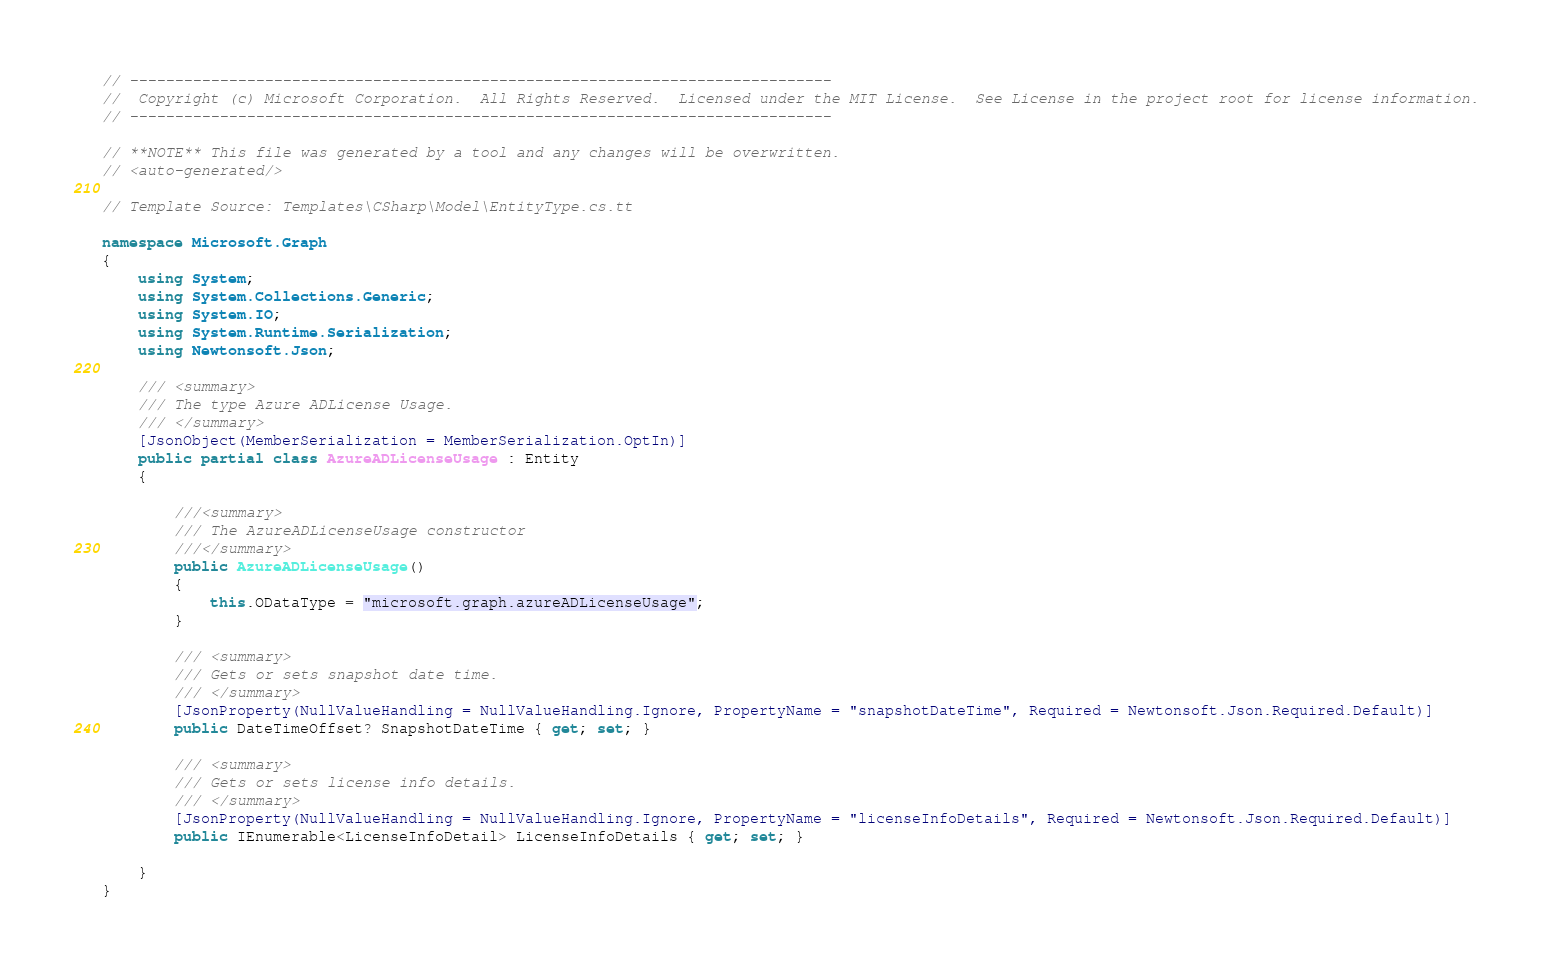Convert code to text. <code><loc_0><loc_0><loc_500><loc_500><_C#_>// ------------------------------------------------------------------------------
//  Copyright (c) Microsoft Corporation.  All Rights Reserved.  Licensed under the MIT License.  See License in the project root for license information.
// ------------------------------------------------------------------------------

// **NOTE** This file was generated by a tool and any changes will be overwritten.
// <auto-generated/>

// Template Source: Templates\CSharp\Model\EntityType.cs.tt

namespace Microsoft.Graph
{
    using System;
    using System.Collections.Generic;
    using System.IO;
    using System.Runtime.Serialization;
    using Newtonsoft.Json;

    /// <summary>
    /// The type Azure ADLicense Usage.
    /// </summary>
    [JsonObject(MemberSerialization = MemberSerialization.OptIn)]
    public partial class AzureADLicenseUsage : Entity
    {
    
		///<summary>
		/// The AzureADLicenseUsage constructor
		///</summary>
        public AzureADLicenseUsage()
        {
            this.ODataType = "microsoft.graph.azureADLicenseUsage";
        }
	
        /// <summary>
        /// Gets or sets snapshot date time.
        /// </summary>
        [JsonProperty(NullValueHandling = NullValueHandling.Ignore, PropertyName = "snapshotDateTime", Required = Newtonsoft.Json.Required.Default)]
        public DateTimeOffset? SnapshotDateTime { get; set; }
    
        /// <summary>
        /// Gets or sets license info details.
        /// </summary>
        [JsonProperty(NullValueHandling = NullValueHandling.Ignore, PropertyName = "licenseInfoDetails", Required = Newtonsoft.Json.Required.Default)]
        public IEnumerable<LicenseInfoDetail> LicenseInfoDetails { get; set; }
    
    }
}

</code> 